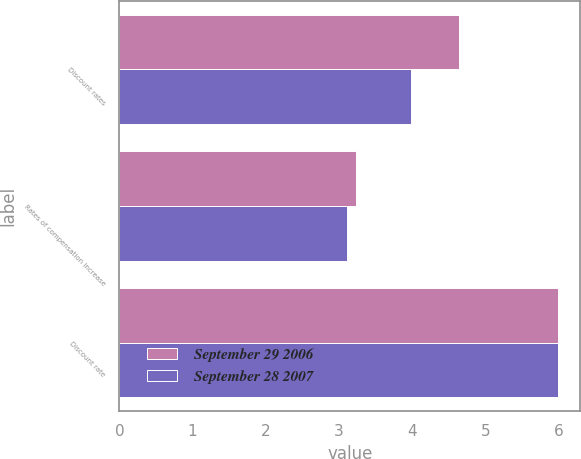Convert chart. <chart><loc_0><loc_0><loc_500><loc_500><stacked_bar_chart><ecel><fcel>Discount rates<fcel>Rates of compensation increase<fcel>Discount rate<nl><fcel>September 29 2006<fcel>4.64<fcel>3.24<fcel>6<nl><fcel>September 28 2007<fcel>3.99<fcel>3.11<fcel>6<nl></chart> 